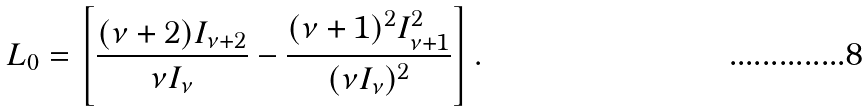Convert formula to latex. <formula><loc_0><loc_0><loc_500><loc_500>L _ { 0 } = \left [ \frac { ( \nu + 2 ) I _ { \nu + 2 } } { \nu { I } _ { \nu } } - \frac { ( \nu + 1 ) ^ { 2 } I _ { \nu + 1 } ^ { 2 } } { ( \nu { I } _ { \nu } ) ^ { 2 } } \right ] .</formula> 